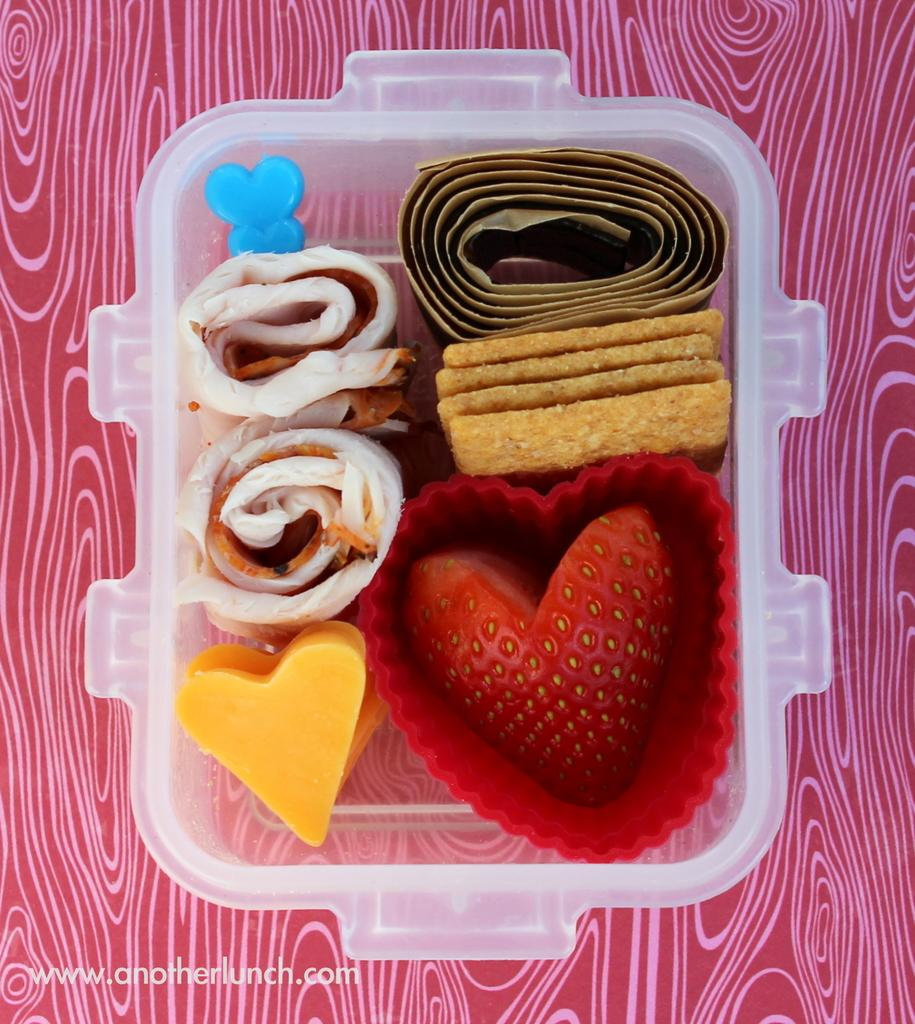What type of objects can be seen in the image? There are food items in the image. Can you describe the setting where the food items are located? There is a box on the table in the image. What type of pipe is visible in the image? There is no pipe present in the image. What type of church can be seen in the background of the image? There is no church visible in the image. 